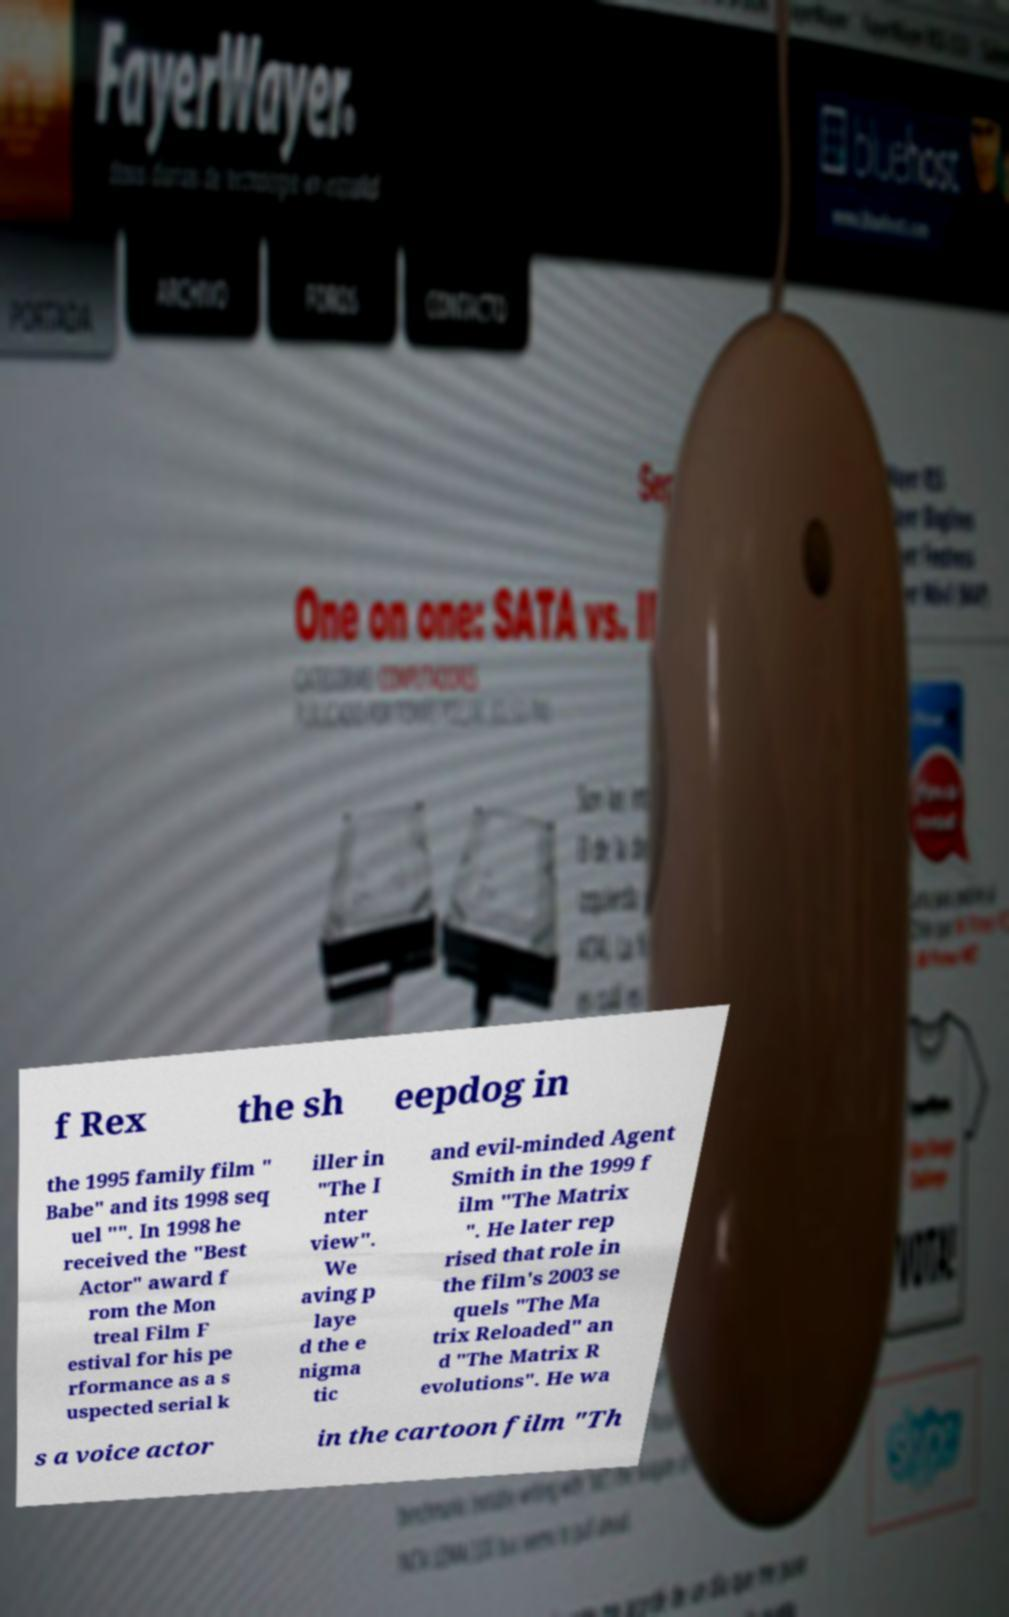Could you extract and type out the text from this image? f Rex the sh eepdog in the 1995 family film " Babe" and its 1998 seq uel "". In 1998 he received the "Best Actor" award f rom the Mon treal Film F estival for his pe rformance as a s uspected serial k iller in "The I nter view". We aving p laye d the e nigma tic and evil-minded Agent Smith in the 1999 f ilm "The Matrix ". He later rep rised that role in the film's 2003 se quels "The Ma trix Reloaded" an d "The Matrix R evolutions". He wa s a voice actor in the cartoon film "Th 